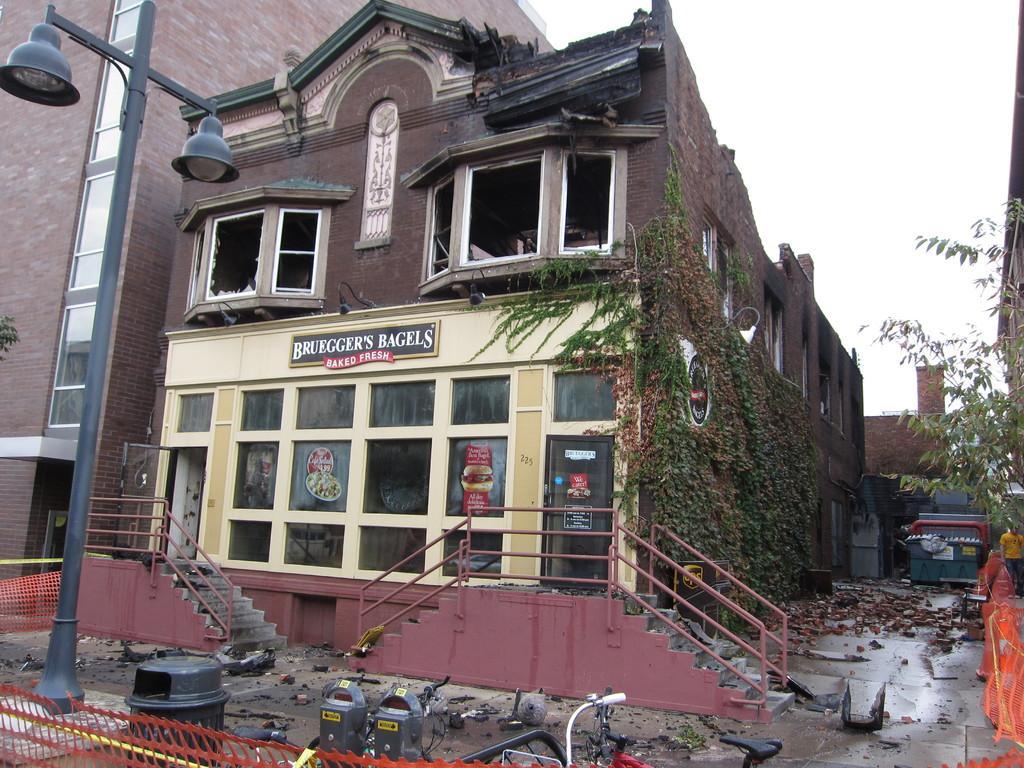Could you give a brief overview of what you see in this image? In this image there are buildings and there are plants on the building and there is some text written on the wall of the building. In front of the building there are staircases and there are railings and there are bicycles, there is a pole. On the right side there are objects which are red in colour and the sky is cloudy. 